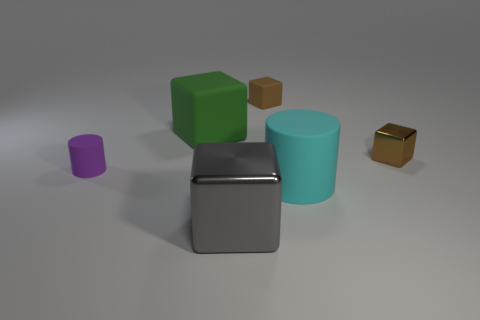Add 2 large metallic objects. How many objects exist? 8 Subtract all cylinders. How many objects are left? 4 Add 5 small cyan matte blocks. How many small cyan matte blocks exist? 5 Subtract 0 red cubes. How many objects are left? 6 Subtract all gray metallic blocks. Subtract all metallic things. How many objects are left? 3 Add 2 shiny cubes. How many shiny cubes are left? 4 